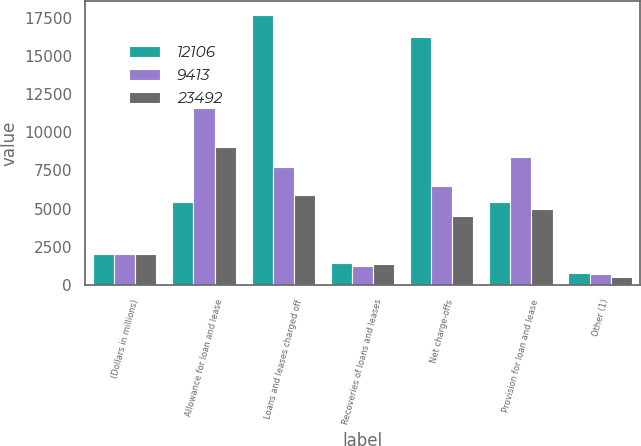<chart> <loc_0><loc_0><loc_500><loc_500><stacked_bar_chart><ecel><fcel>(Dollars in millions)<fcel>Allowance for loan and lease<fcel>Loans and leases charged off<fcel>Recoveries of loans and leases<fcel>Net charge-offs<fcel>Provision for loan and lease<fcel>Other (1)<nl><fcel>12106<fcel>2008<fcel>5441<fcel>17666<fcel>1435<fcel>16231<fcel>5441<fcel>792<nl><fcel>9413<fcel>2007<fcel>11588<fcel>7730<fcel>1250<fcel>6480<fcel>8357<fcel>727<nl><fcel>23492<fcel>2006<fcel>9016<fcel>5881<fcel>1342<fcel>4539<fcel>5001<fcel>509<nl></chart> 